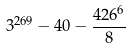<formula> <loc_0><loc_0><loc_500><loc_500>3 ^ { 2 6 9 } - 4 0 - \frac { 4 2 6 ^ { 6 } } { 8 }</formula> 